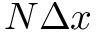Convert formula to latex. <formula><loc_0><loc_0><loc_500><loc_500>N \Delta x</formula> 